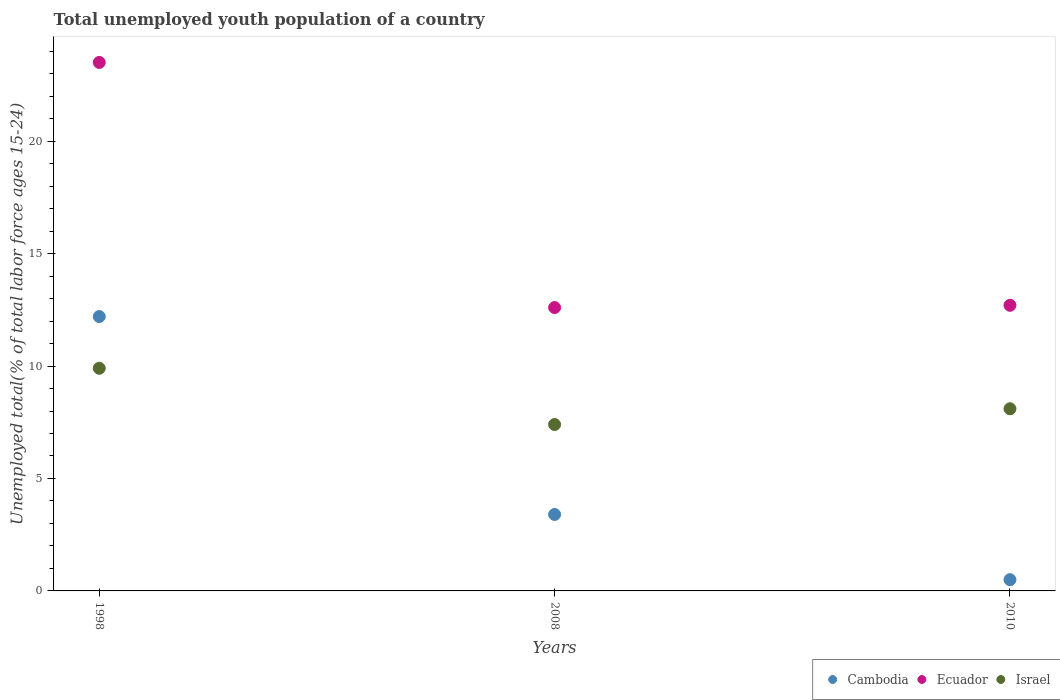Is the number of dotlines equal to the number of legend labels?
Give a very brief answer. Yes. What is the percentage of total unemployed youth population of a country in Cambodia in 1998?
Provide a succinct answer. 12.2. Across all years, what is the maximum percentage of total unemployed youth population of a country in Israel?
Offer a very short reply. 9.9. Across all years, what is the minimum percentage of total unemployed youth population of a country in Israel?
Make the answer very short. 7.4. In which year was the percentage of total unemployed youth population of a country in Cambodia maximum?
Provide a succinct answer. 1998. In which year was the percentage of total unemployed youth population of a country in Ecuador minimum?
Offer a very short reply. 2008. What is the total percentage of total unemployed youth population of a country in Israel in the graph?
Your response must be concise. 25.4. What is the difference between the percentage of total unemployed youth population of a country in Cambodia in 2008 and that in 2010?
Give a very brief answer. 2.9. What is the difference between the percentage of total unemployed youth population of a country in Israel in 1998 and the percentage of total unemployed youth population of a country in Cambodia in 2008?
Your answer should be very brief. 6.5. What is the average percentage of total unemployed youth population of a country in Ecuador per year?
Provide a succinct answer. 16.27. In the year 1998, what is the difference between the percentage of total unemployed youth population of a country in Cambodia and percentage of total unemployed youth population of a country in Israel?
Your answer should be very brief. 2.3. What is the ratio of the percentage of total unemployed youth population of a country in Israel in 1998 to that in 2008?
Your answer should be compact. 1.34. What is the difference between the highest and the second highest percentage of total unemployed youth population of a country in Cambodia?
Offer a terse response. 8.8. What is the difference between the highest and the lowest percentage of total unemployed youth population of a country in Cambodia?
Ensure brevity in your answer.  11.7. In how many years, is the percentage of total unemployed youth population of a country in Cambodia greater than the average percentage of total unemployed youth population of a country in Cambodia taken over all years?
Your answer should be compact. 1. Is it the case that in every year, the sum of the percentage of total unemployed youth population of a country in Cambodia and percentage of total unemployed youth population of a country in Ecuador  is greater than the percentage of total unemployed youth population of a country in Israel?
Offer a terse response. Yes. Does the percentage of total unemployed youth population of a country in Cambodia monotonically increase over the years?
Offer a terse response. No. Is the percentage of total unemployed youth population of a country in Ecuador strictly less than the percentage of total unemployed youth population of a country in Cambodia over the years?
Give a very brief answer. No. How many dotlines are there?
Your answer should be compact. 3. How many years are there in the graph?
Keep it short and to the point. 3. What is the difference between two consecutive major ticks on the Y-axis?
Keep it short and to the point. 5. Does the graph contain any zero values?
Your response must be concise. No. Does the graph contain grids?
Ensure brevity in your answer.  No. What is the title of the graph?
Provide a succinct answer. Total unemployed youth population of a country. Does "High income" appear as one of the legend labels in the graph?
Your answer should be compact. No. What is the label or title of the Y-axis?
Offer a terse response. Unemployed total(% of total labor force ages 15-24). What is the Unemployed total(% of total labor force ages 15-24) in Cambodia in 1998?
Provide a succinct answer. 12.2. What is the Unemployed total(% of total labor force ages 15-24) of Israel in 1998?
Your response must be concise. 9.9. What is the Unemployed total(% of total labor force ages 15-24) of Cambodia in 2008?
Make the answer very short. 3.4. What is the Unemployed total(% of total labor force ages 15-24) of Ecuador in 2008?
Offer a terse response. 12.6. What is the Unemployed total(% of total labor force ages 15-24) of Israel in 2008?
Provide a short and direct response. 7.4. What is the Unemployed total(% of total labor force ages 15-24) in Cambodia in 2010?
Make the answer very short. 0.5. What is the Unemployed total(% of total labor force ages 15-24) of Ecuador in 2010?
Provide a succinct answer. 12.7. What is the Unemployed total(% of total labor force ages 15-24) of Israel in 2010?
Offer a terse response. 8.1. Across all years, what is the maximum Unemployed total(% of total labor force ages 15-24) in Cambodia?
Keep it short and to the point. 12.2. Across all years, what is the maximum Unemployed total(% of total labor force ages 15-24) of Ecuador?
Ensure brevity in your answer.  23.5. Across all years, what is the maximum Unemployed total(% of total labor force ages 15-24) of Israel?
Offer a terse response. 9.9. Across all years, what is the minimum Unemployed total(% of total labor force ages 15-24) of Cambodia?
Your answer should be very brief. 0.5. Across all years, what is the minimum Unemployed total(% of total labor force ages 15-24) of Ecuador?
Provide a succinct answer. 12.6. Across all years, what is the minimum Unemployed total(% of total labor force ages 15-24) of Israel?
Your answer should be compact. 7.4. What is the total Unemployed total(% of total labor force ages 15-24) of Cambodia in the graph?
Give a very brief answer. 16.1. What is the total Unemployed total(% of total labor force ages 15-24) of Ecuador in the graph?
Give a very brief answer. 48.8. What is the total Unemployed total(% of total labor force ages 15-24) in Israel in the graph?
Your answer should be very brief. 25.4. What is the difference between the Unemployed total(% of total labor force ages 15-24) of Israel in 1998 and that in 2008?
Your answer should be compact. 2.5. What is the difference between the Unemployed total(% of total labor force ages 15-24) of Cambodia in 1998 and that in 2010?
Provide a succinct answer. 11.7. What is the difference between the Unemployed total(% of total labor force ages 15-24) of Israel in 2008 and that in 2010?
Offer a terse response. -0.7. What is the difference between the Unemployed total(% of total labor force ages 15-24) in Cambodia in 1998 and the Unemployed total(% of total labor force ages 15-24) in Ecuador in 2008?
Ensure brevity in your answer.  -0.4. What is the difference between the Unemployed total(% of total labor force ages 15-24) in Cambodia in 1998 and the Unemployed total(% of total labor force ages 15-24) in Israel in 2008?
Keep it short and to the point. 4.8. What is the difference between the Unemployed total(% of total labor force ages 15-24) of Ecuador in 1998 and the Unemployed total(% of total labor force ages 15-24) of Israel in 2008?
Ensure brevity in your answer.  16.1. What is the difference between the Unemployed total(% of total labor force ages 15-24) of Cambodia in 1998 and the Unemployed total(% of total labor force ages 15-24) of Ecuador in 2010?
Provide a succinct answer. -0.5. What is the difference between the Unemployed total(% of total labor force ages 15-24) in Cambodia in 2008 and the Unemployed total(% of total labor force ages 15-24) in Israel in 2010?
Ensure brevity in your answer.  -4.7. What is the difference between the Unemployed total(% of total labor force ages 15-24) in Ecuador in 2008 and the Unemployed total(% of total labor force ages 15-24) in Israel in 2010?
Offer a terse response. 4.5. What is the average Unemployed total(% of total labor force ages 15-24) in Cambodia per year?
Provide a short and direct response. 5.37. What is the average Unemployed total(% of total labor force ages 15-24) of Ecuador per year?
Keep it short and to the point. 16.27. What is the average Unemployed total(% of total labor force ages 15-24) in Israel per year?
Keep it short and to the point. 8.47. In the year 1998, what is the difference between the Unemployed total(% of total labor force ages 15-24) of Cambodia and Unemployed total(% of total labor force ages 15-24) of Israel?
Provide a short and direct response. 2.3. In the year 2008, what is the difference between the Unemployed total(% of total labor force ages 15-24) in Cambodia and Unemployed total(% of total labor force ages 15-24) in Ecuador?
Your answer should be compact. -9.2. In the year 2008, what is the difference between the Unemployed total(% of total labor force ages 15-24) in Cambodia and Unemployed total(% of total labor force ages 15-24) in Israel?
Offer a terse response. -4. In the year 2008, what is the difference between the Unemployed total(% of total labor force ages 15-24) in Ecuador and Unemployed total(% of total labor force ages 15-24) in Israel?
Provide a succinct answer. 5.2. In the year 2010, what is the difference between the Unemployed total(% of total labor force ages 15-24) in Ecuador and Unemployed total(% of total labor force ages 15-24) in Israel?
Provide a short and direct response. 4.6. What is the ratio of the Unemployed total(% of total labor force ages 15-24) in Cambodia in 1998 to that in 2008?
Ensure brevity in your answer.  3.59. What is the ratio of the Unemployed total(% of total labor force ages 15-24) in Ecuador in 1998 to that in 2008?
Make the answer very short. 1.87. What is the ratio of the Unemployed total(% of total labor force ages 15-24) in Israel in 1998 to that in 2008?
Offer a terse response. 1.34. What is the ratio of the Unemployed total(% of total labor force ages 15-24) in Cambodia in 1998 to that in 2010?
Make the answer very short. 24.4. What is the ratio of the Unemployed total(% of total labor force ages 15-24) of Ecuador in 1998 to that in 2010?
Make the answer very short. 1.85. What is the ratio of the Unemployed total(% of total labor force ages 15-24) of Israel in 1998 to that in 2010?
Make the answer very short. 1.22. What is the ratio of the Unemployed total(% of total labor force ages 15-24) of Ecuador in 2008 to that in 2010?
Offer a very short reply. 0.99. What is the ratio of the Unemployed total(% of total labor force ages 15-24) of Israel in 2008 to that in 2010?
Provide a short and direct response. 0.91. What is the difference between the highest and the second highest Unemployed total(% of total labor force ages 15-24) in Cambodia?
Give a very brief answer. 8.8. What is the difference between the highest and the second highest Unemployed total(% of total labor force ages 15-24) in Ecuador?
Your response must be concise. 10.8. What is the difference between the highest and the lowest Unemployed total(% of total labor force ages 15-24) in Ecuador?
Your answer should be very brief. 10.9. 